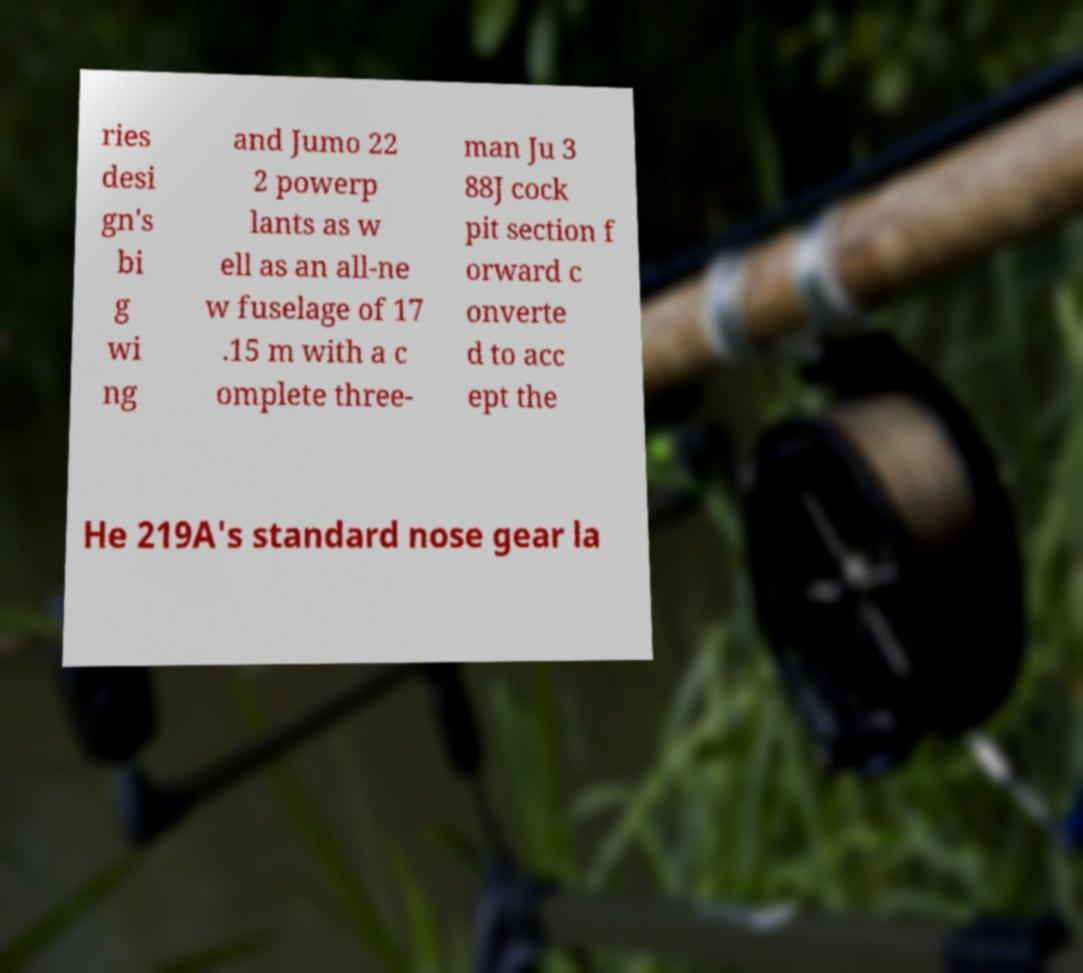Could you extract and type out the text from this image? ries desi gn's bi g wi ng and Jumo 22 2 powerp lants as w ell as an all-ne w fuselage of 17 .15 m with a c omplete three- man Ju 3 88J cock pit section f orward c onverte d to acc ept the He 219A's standard nose gear la 